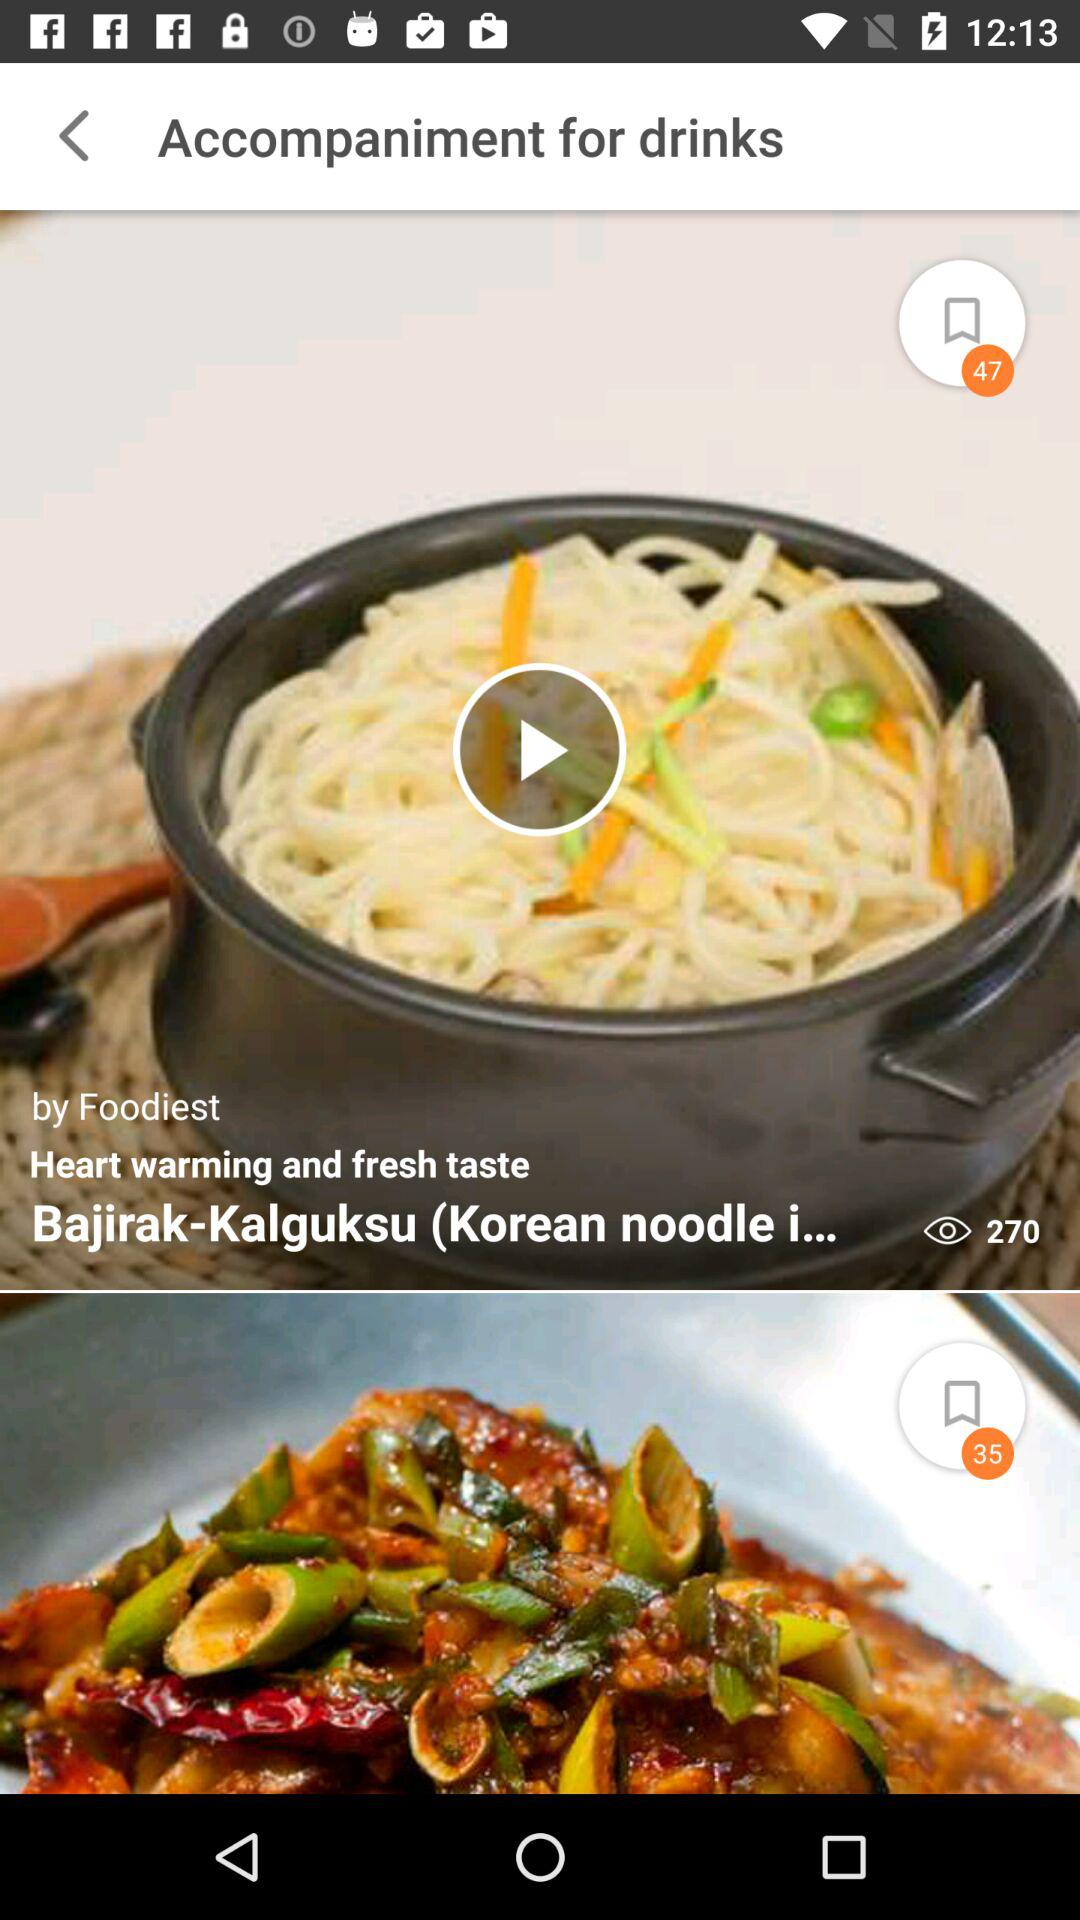How many comments are on "Bajirak-Kalguksu"?
When the provided information is insufficient, respond with <no answer>. <no answer> 